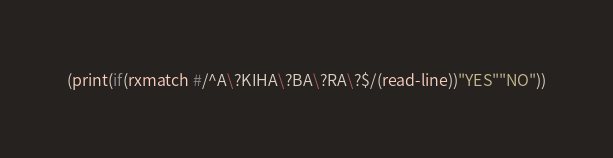<code> <loc_0><loc_0><loc_500><loc_500><_Scheme_>(print(if(rxmatch #/^A\?KIHA\?BA\?RA\?$/(read-line))"YES""NO"))</code> 